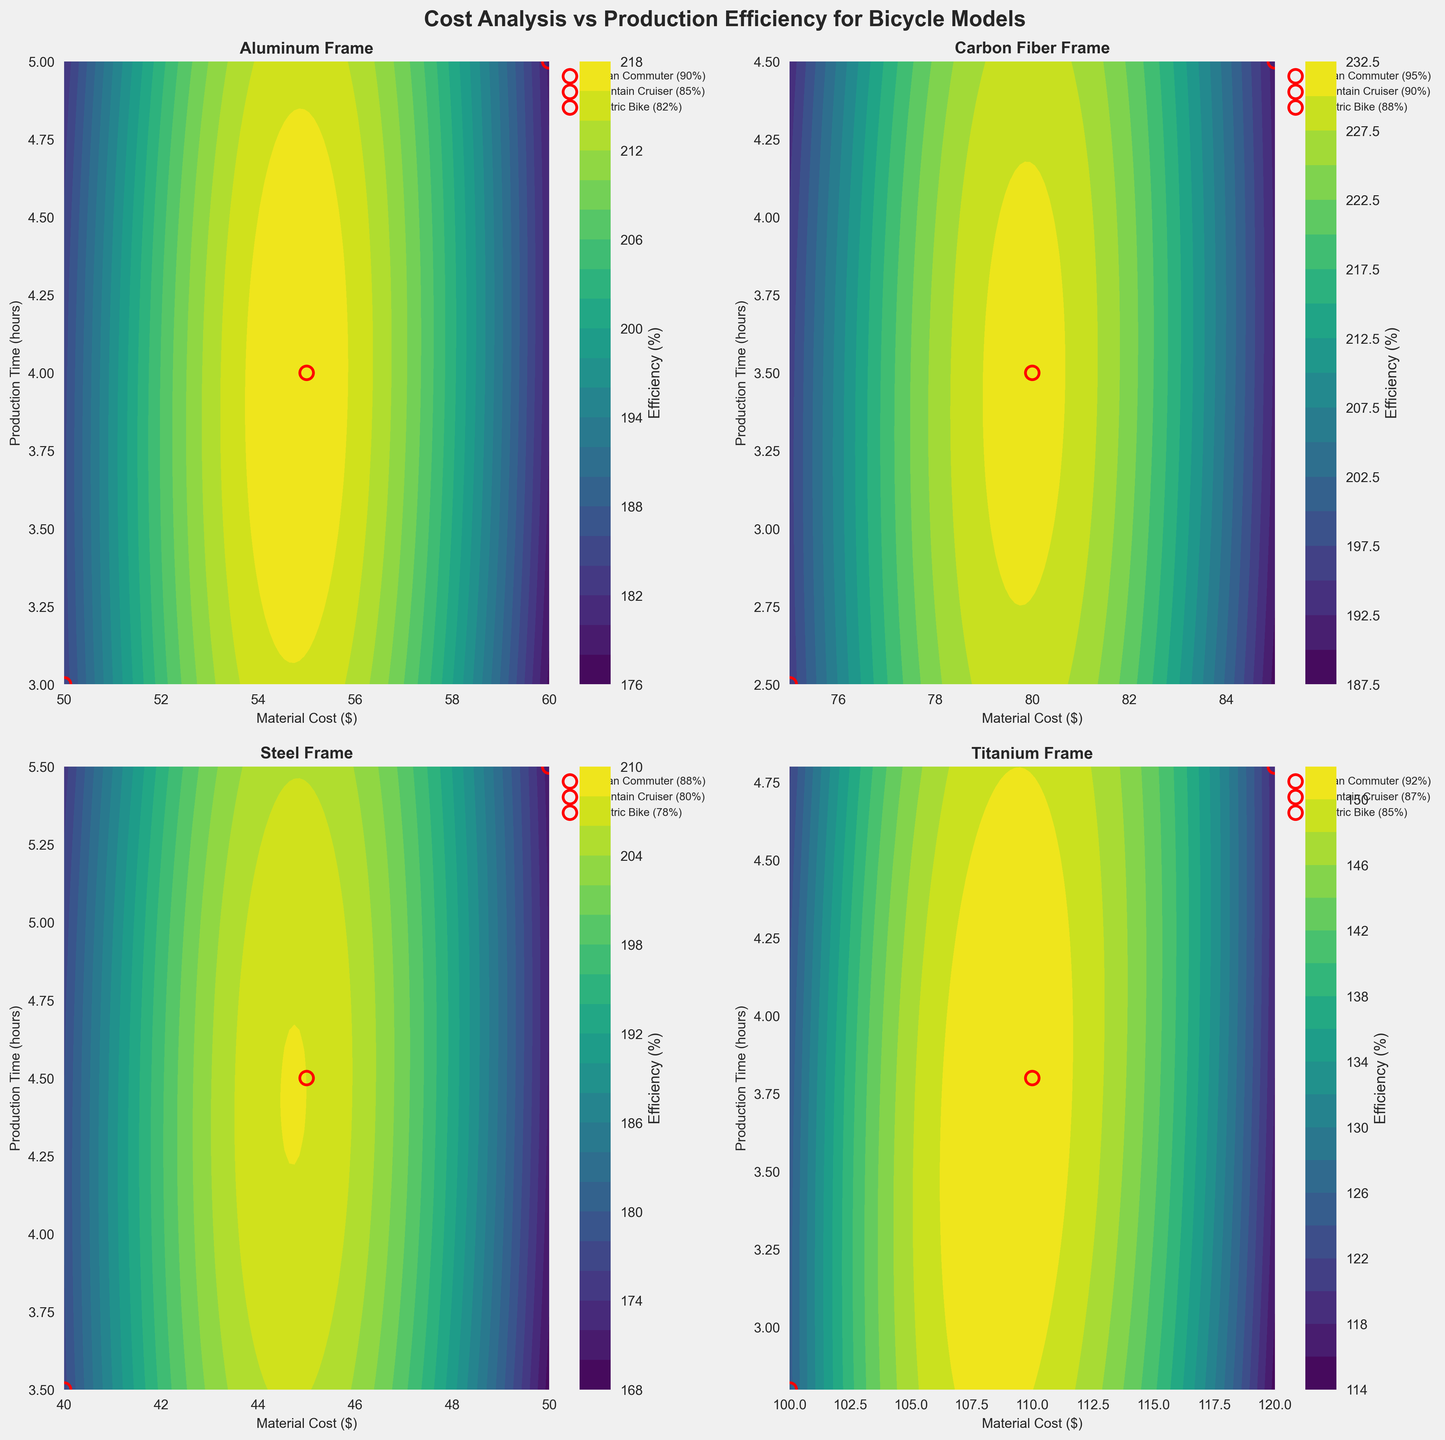What's the title of this figure? The title is displayed at the top center of the figure, which reads "Cost Analysis vs Production Efficiency for Bicycle Models".
Answer: Cost Analysis vs Production Efficiency for Bicycle Models How many materials are compared in the figure? Each subplot corresponds to a different material, and there are four subplots shown.
Answer: Four Which material shows the highest efficiency for the Mountain Cruiser model? Look at the legend in the subplot for each material and find the model labeled "Mountain Cruiser". From the values, "Carbon Fiber Frame" has the highest efficiency of 90%.
Answer: Carbon Fiber Frame What are the x-axis and y-axis labels of each subplot? The x-axis label is "Material Cost ($)" and the y-axis label is "Production Time (hours)" for all subplots.
Answer: Material Cost ($), Production Time (hours) For which material, the Urban Commuter model has the lowest production time? Go through each subplot and find the production time for the Urban Commuter model indicated in the legend. "Carbon Fiber Frame" has the lowest production time of 2.5 hours.
Answer: Carbon Fiber Frame Which subplot shows the lowest efficiency for the Electric Bike model? Compare the efficiency values labeled for the Electric Bike model in each subplot. The "Steel Frame" shows the lowest efficiency of 78%.
Answer: Steel Frame Order the production times for the Electric Bike model from shortest to longest. Look at the scatter points for the Electric Bike model in each subplot and note the production times. The order from shortest to longest is Carbon Fiber Frame (4.5 hours), Titanium Frame (4.8 hours), Aluminum Frame (5 hours), Steel Frame (5.5 hours).
Answer: Carbon Fiber Frame, Titanium Frame, Aluminum Frame, Steel Frame Which material has the widest efficiency range between the Urban Commuter and Electric Bike models? Calculate the efficiency range for Urban Commuter and Electric Bike models by subtracting their efficiencies. "Titanium Frame" has the widest range: 92 - 85 = 7.
Answer: Titanium Frame Which models have the same efficiency for any material? Compare the efficiency values across different materials. No two models share the same efficiency across all materials.
Answer: None 